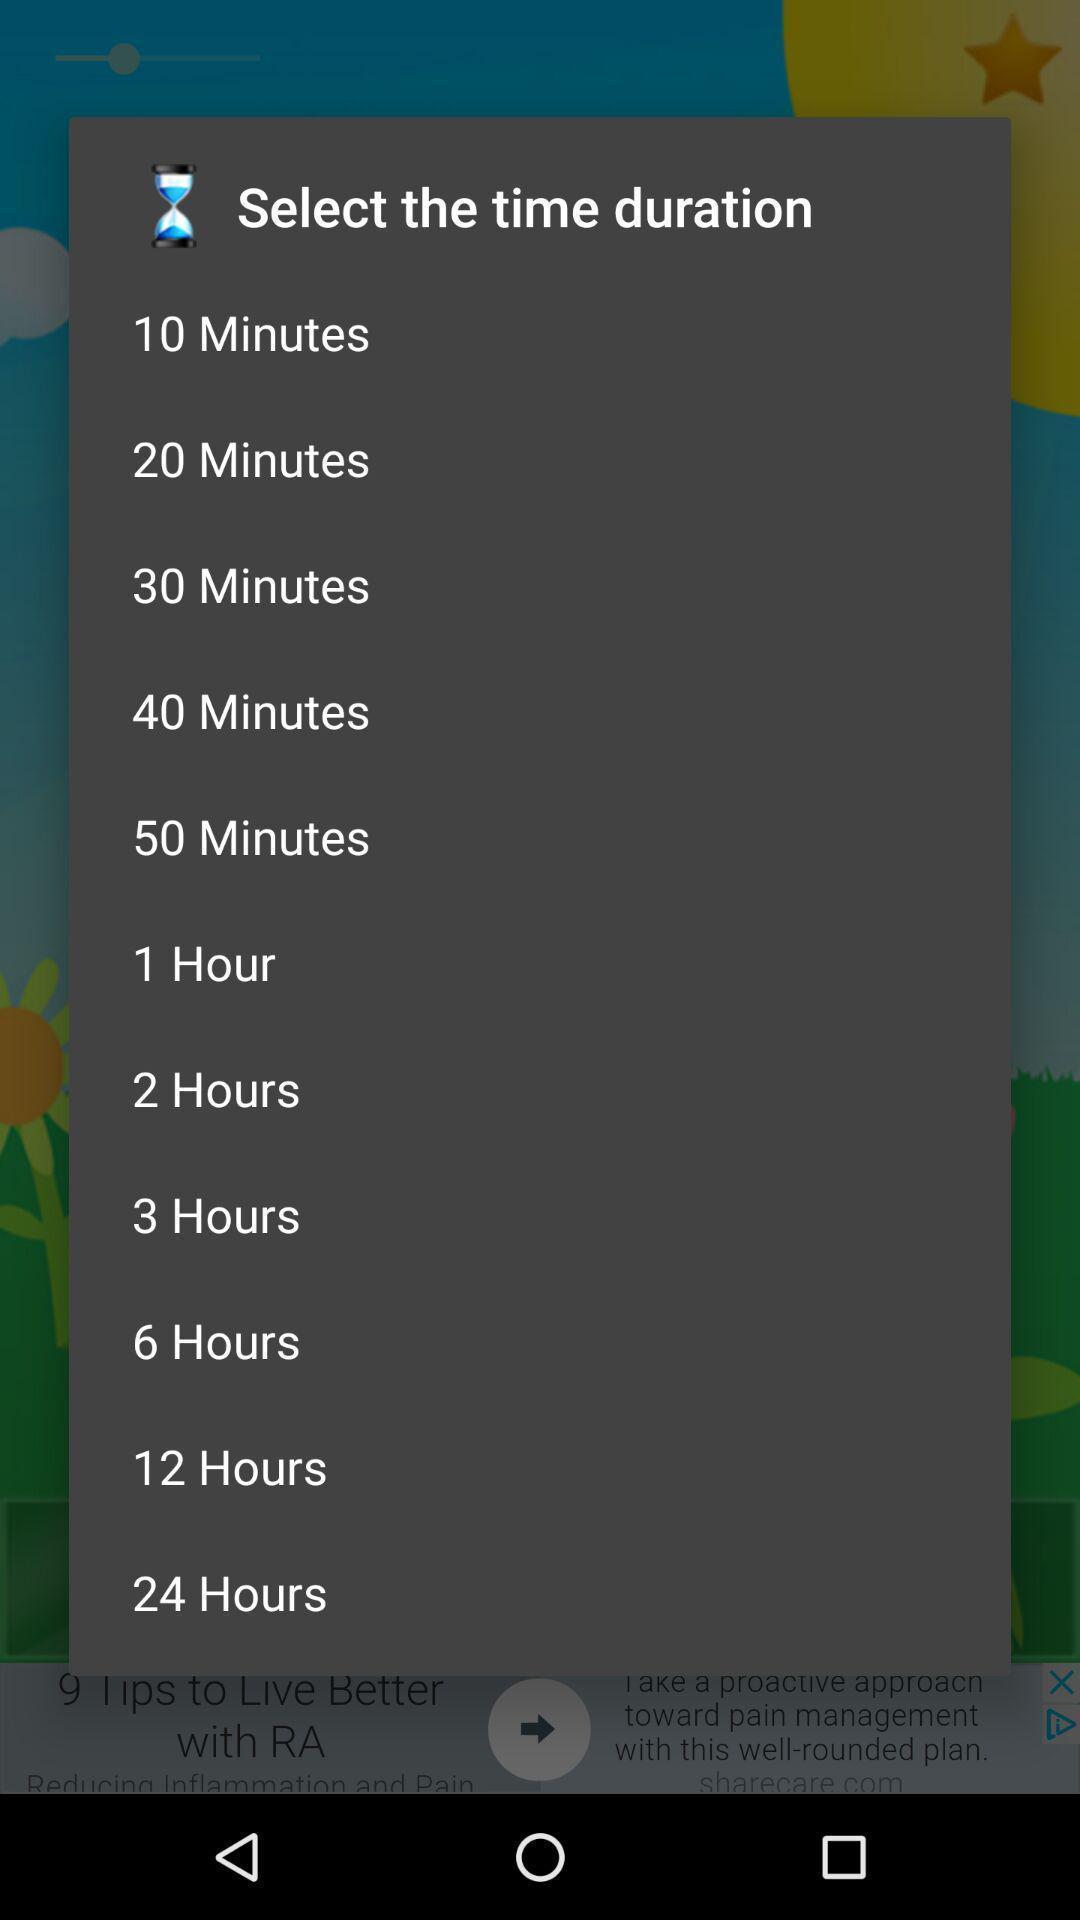Provide a textual representation of this image. Popup displaying time duration. 